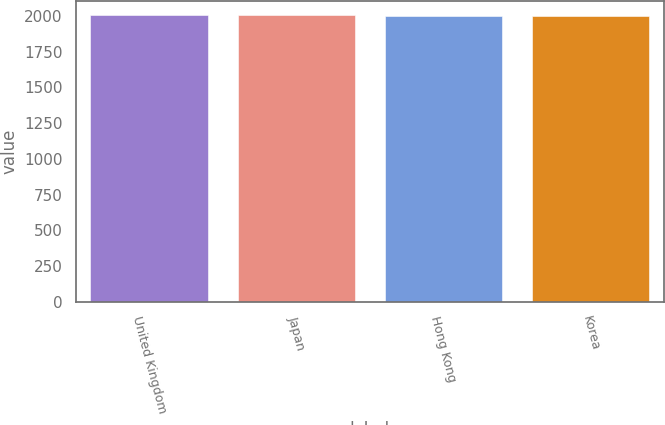Convert chart. <chart><loc_0><loc_0><loc_500><loc_500><bar_chart><fcel>United Kingdom<fcel>Japan<fcel>Hong Kong<fcel>Korea<nl><fcel>2005<fcel>2005.2<fcel>2003<fcel>2003.2<nl></chart> 